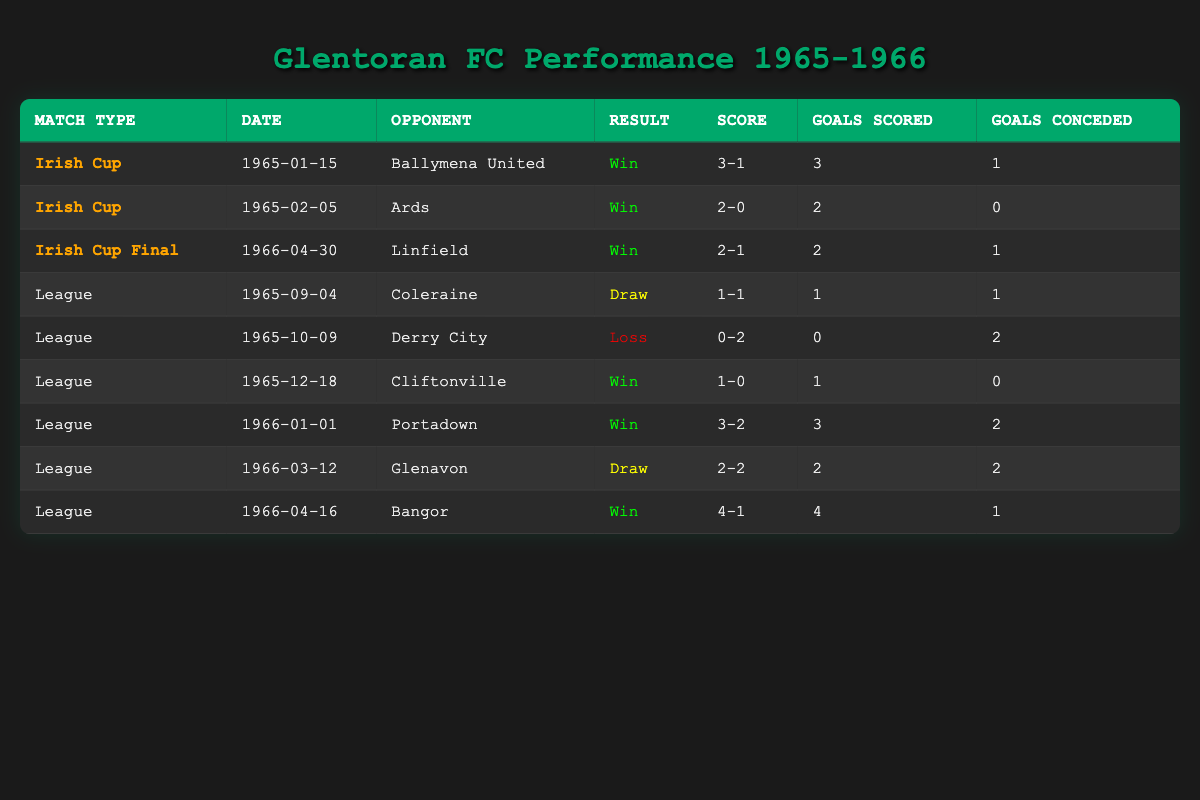What was the result of the Irish Cup Final match? The table states that the Irish Cup Final match was on 1966-04-30 against Linfield, and Glentoran FC won the match with a score of 2-1.
Answer: Win How many matches did Glentoran FC win in the Irish Cup from 1965 to 1966? In the table, Glentoran FC won three matches in the Irish Cup: against Ballymena United (3-1), Ards (2-0), and Linfield in the final (2-1). Summing these gives a total of three wins.
Answer: 3 What was Glentoran FC's result in their league match against Derry City? According to the table, the match against Derry City on 1965-10-09 resulted in a loss for Glentoran FC with a score of 0-2.
Answer: Loss What was the average number of goals scored by Glentoran FC in the Irish Cup matches? For the Irish Cup matches, Glentoran FC scored 3 goals against Ballymena United, 2 goals against Ards, and 2 goals in the final against Linfield. The total goals scored is 3 + 2 + 2 = 7. Since there are 3 matches, the average is 7/3 = approximately 2.33.
Answer: 2.33 Did Glentoran FC secure any draws in their league matches? Reviewing the league results, there were two draws noted: one against Coleraine (1-1) and another against Glenavon (2-2). This confirms that Glentoran FC had draws in their league matches.
Answer: Yes What is the total number of goals conceded by Glentoran FC in league matches? In the league matches, the goals conceded by Glentoran FC were as follows: 1 (Coleraine), 2 (Derry City), 0 (Cliftonville), 2 (Portadown), 2 (Glenavon), and 1 (Bangor). Summing these gives 1 + 2 + 0 + 2 + 2 + 1 = 8 goals conceded.
Answer: 8 Which opponent did Glentoran FC score the most goals against in league matches? Analyzing the league results, Glentoran FC scored the most against Bangor with 4 goals (4-1). Thus, Bangor is the opponent with the highest goals scored by Glentoran FC in league matches.
Answer: Bangor What is the overall result of Glentoran FC in Irish Cup matches during this period? In the Irish Cup matches, Glentoran FC won all three matches. Therefore, the overall result in the Irish Cup during this period is that they won every match.
Answer: All wins 